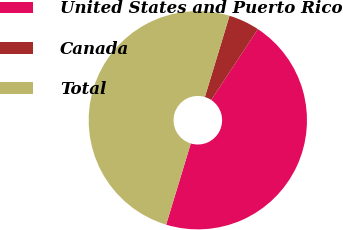Convert chart to OTSL. <chart><loc_0><loc_0><loc_500><loc_500><pie_chart><fcel>United States and Puerto Rico<fcel>Canada<fcel>Total<nl><fcel>45.41%<fcel>4.59%<fcel>50.0%<nl></chart> 